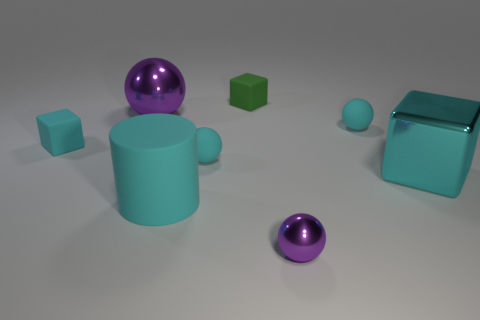If this were a scene from a game, what genre would it likely be a part of? If this were part of a game, the abstract shapes and clean lines might suggest a puzzle or strategy game, where players manipulate or place these objects to solve levels or create structures. 